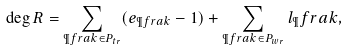<formula> <loc_0><loc_0><loc_500><loc_500>\deg R = \sum _ { \P f r a k \in P _ { t r } } ( e _ { \P f r a k } - 1 ) + \sum _ { \P f r a k \in P _ { w r } } l _ { \P } f r a k ,</formula> 